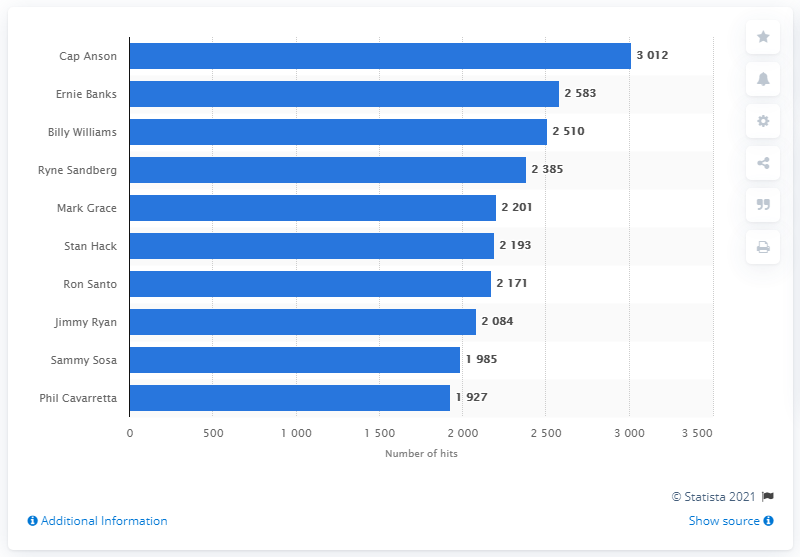Draw attention to some important aspects in this diagram. The individual who holds the record for the most hits in the history of the Chicago Cubs franchise is Cap Anson. 